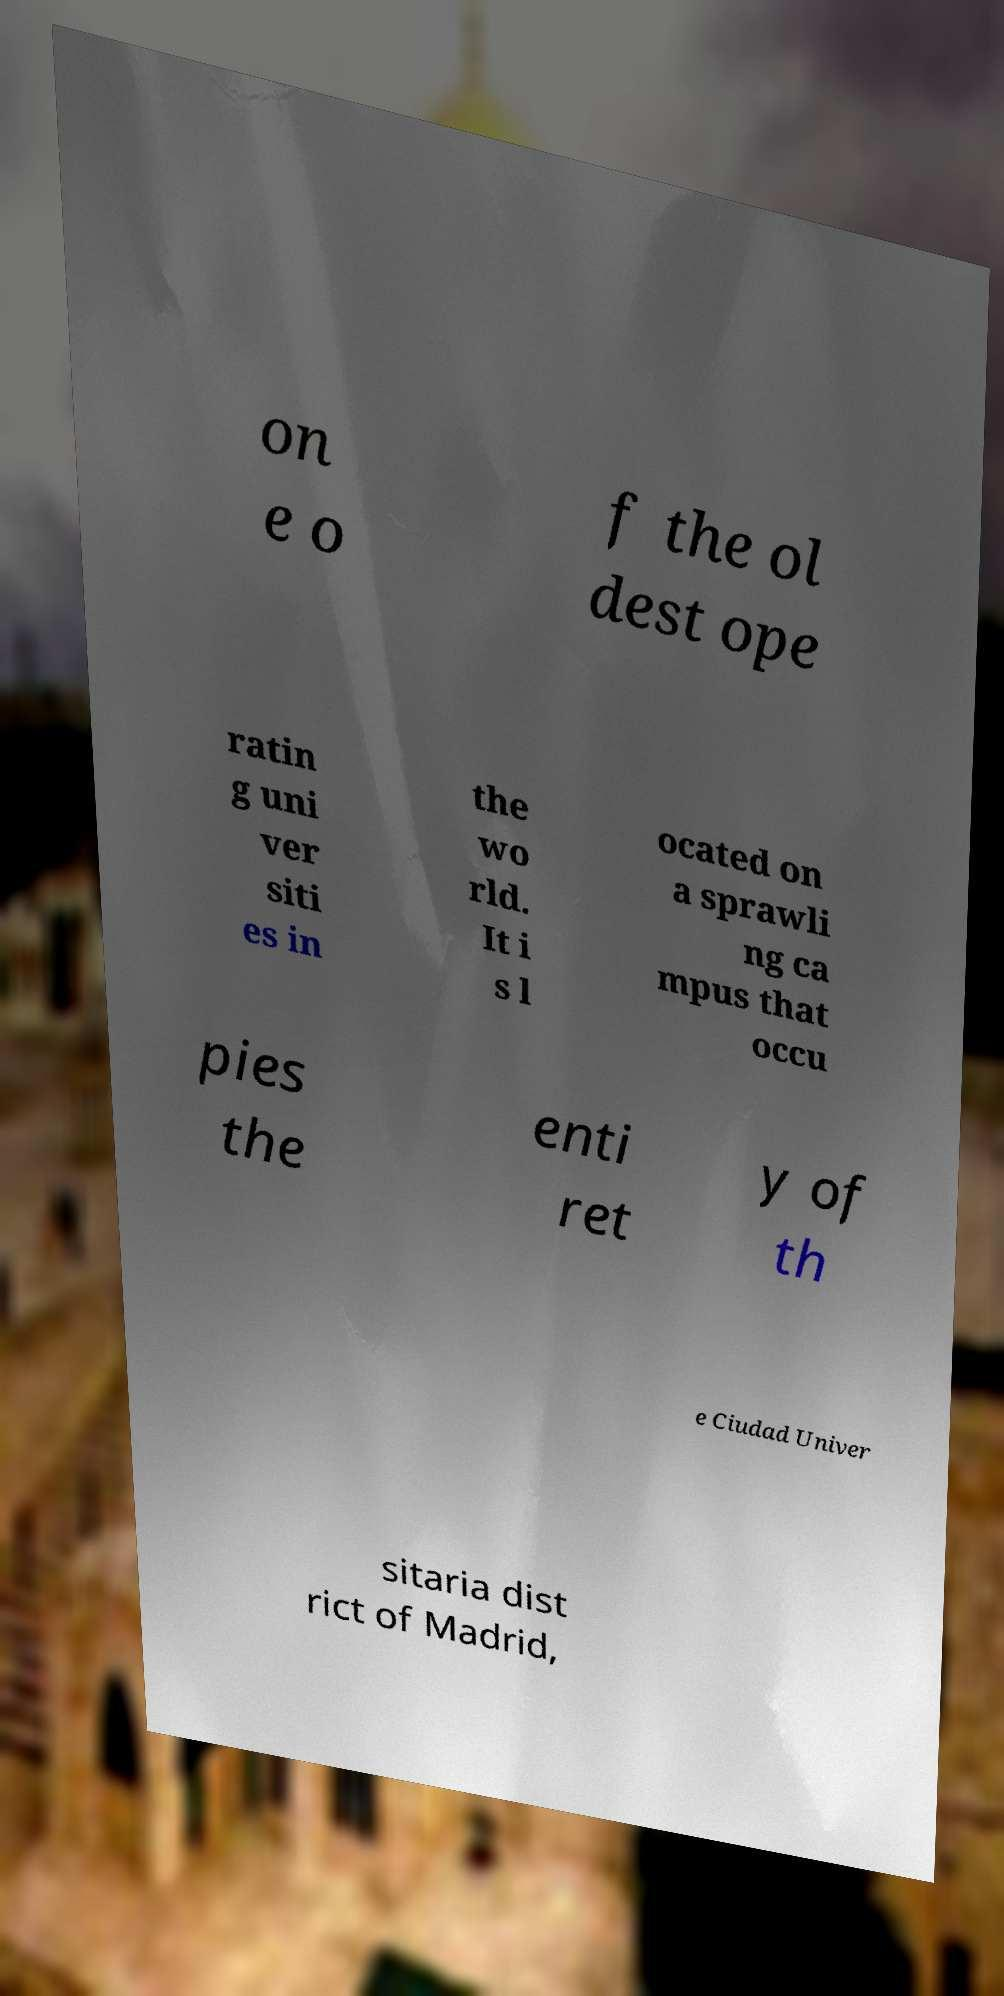Can you accurately transcribe the text from the provided image for me? on e o f the ol dest ope ratin g uni ver siti es in the wo rld. It i s l ocated on a sprawli ng ca mpus that occu pies the enti ret y of th e Ciudad Univer sitaria dist rict of Madrid, 